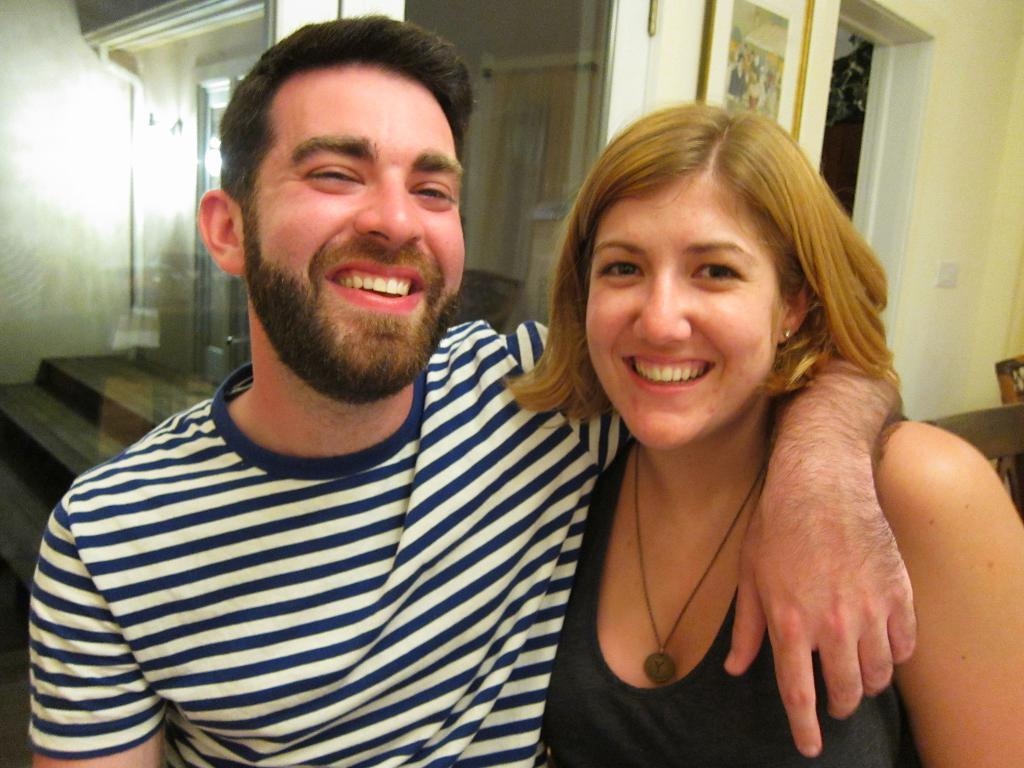How many people are present in the image? There are two people, a man and a woman, present in the image. What expressions do the man and woman have in the image? Both the man and woman are smiling in the image. What can be seen in the background of the image? There is a glass wall, steps, a wall with a photo frame, and a door in the background of the image. Can you describe the setting where the man and woman are located? The man and woman are located in a space with a glass wall, steps, and a door in the background, which suggests it might be an indoor area with multiple levels. What type of oatmeal is being prepared in the image? There is no oatmeal present in the image, nor is there any indication of food preparation. What flavor of kettle can be seen in the image? There is no kettle present in the image, so it is not possible to determine its flavor. 